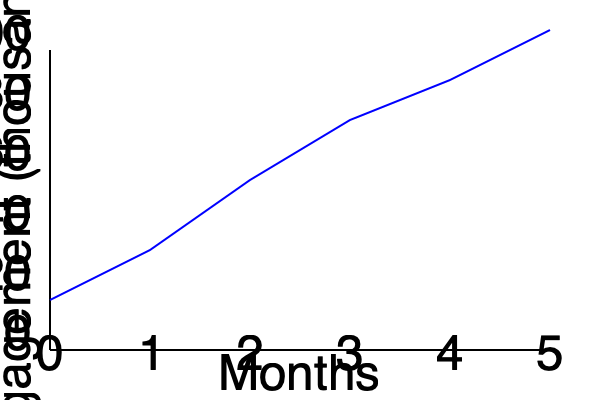The line graph shows the growth of social media engagement for a medication awareness campaign over 5 months. What was the approximate percentage increase in engagement from month 1 to month 4? To calculate the percentage increase in engagement from month 1 to month 4:

1. Identify the engagement values:
   Month 1: approximately 25,000
   Month 4: approximately 85,000

2. Calculate the difference:
   $85,000 - 25,000 = 60,000$

3. Divide the increase by the original value:
   $\frac{60,000}{25,000} = 2.4$

4. Convert to percentage:
   $2.4 \times 100\% = 240\%$

Therefore, the approximate percentage increase in engagement from month 1 to month 4 was 240%.
Answer: 240% 